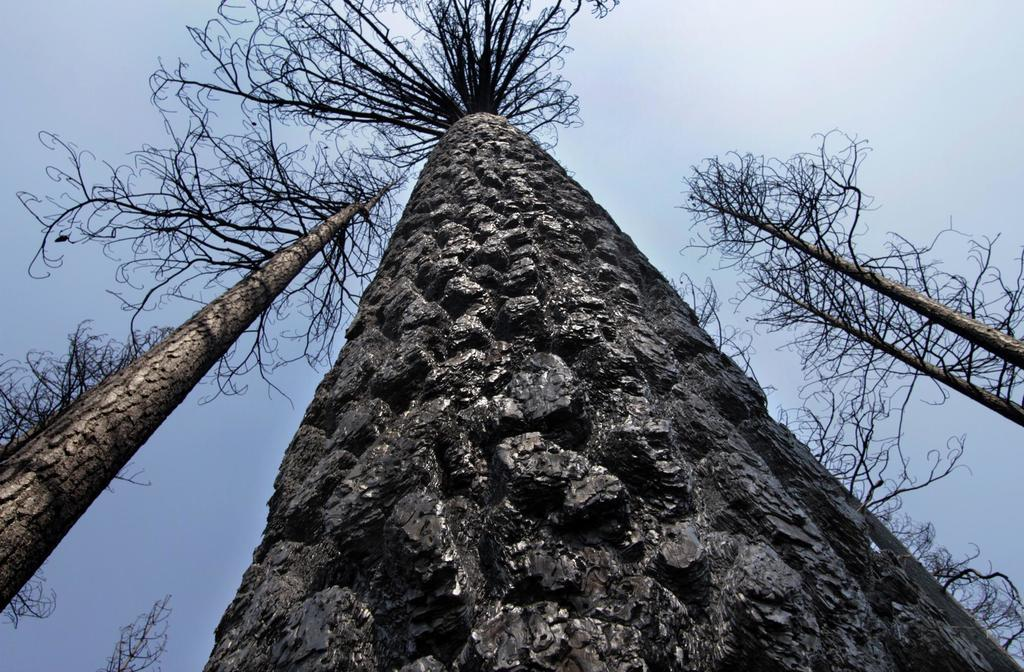What type of vegetation can be seen in the image? There are trees in the image. What part of the natural environment is visible in the image? The sky is visible in the image. What type of ink can be seen dripping from the trees in the image? There is no ink present in the image; it features trees and the sky. What type of pest can be seen crawling on the trees in the image? There are no pests visible on the trees in the image; it only shows trees and the sky. 